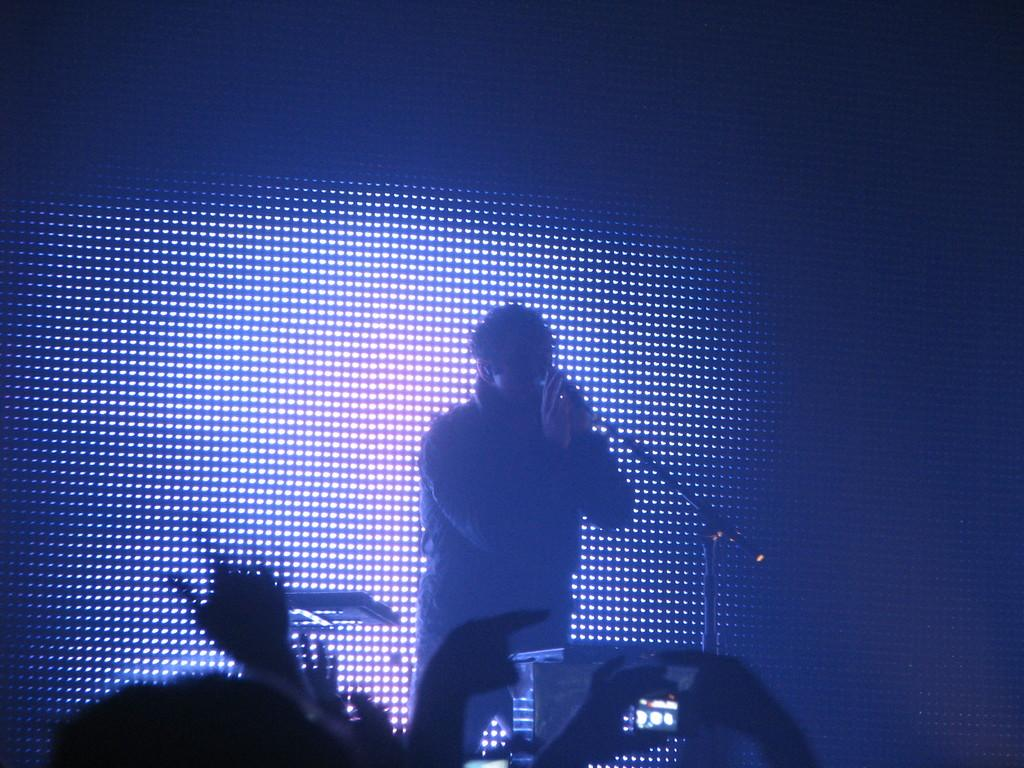What is the person in the image doing? The person is singing in the image. What can be seen in front of the person? There are objects and an audience in front of the person. What is the person using to amplify their voice? The person is in front of a microphone. What is visible behind the person? There are lights visible behind the person. How many dimes are scattered on the floor in front of the person? There are no dimes visible in the image; it only shows the person singing, a microphone, objects, an audience, and lights. 